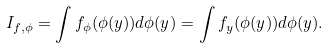Convert formula to latex. <formula><loc_0><loc_0><loc_500><loc_500>I _ { f , \phi } = \int f _ { \phi } ( \phi ( y ) ) d \phi ( y ) = \int f _ { y } ( \phi ( y ) ) d \phi ( y ) .</formula> 